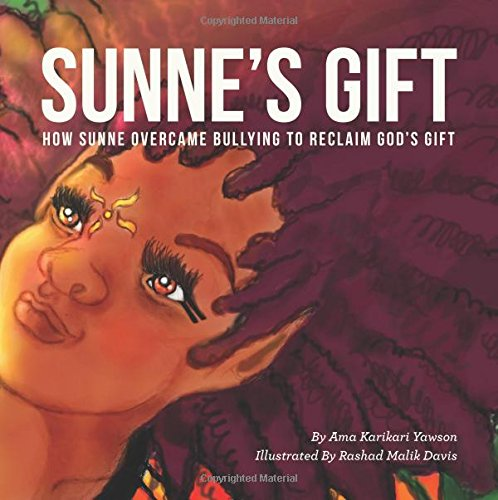Is this a kids book? Yes, it is indeed a children's book, designed to engage younger readers with meaningful stories and vibrant illustrations. 